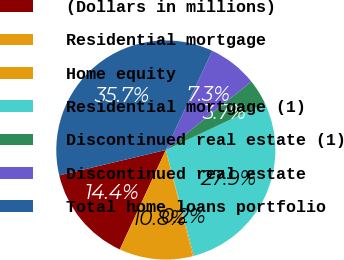Convert chart. <chart><loc_0><loc_0><loc_500><loc_500><pie_chart><fcel>(Dollars in millions)<fcel>Residential mortgage<fcel>Home equity<fcel>Residential mortgage (1)<fcel>Discontinued real estate (1)<fcel>Discontinued real estate<fcel>Total home loans portfolio<nl><fcel>14.39%<fcel>10.84%<fcel>0.18%<fcel>27.88%<fcel>3.74%<fcel>7.29%<fcel>35.69%<nl></chart> 